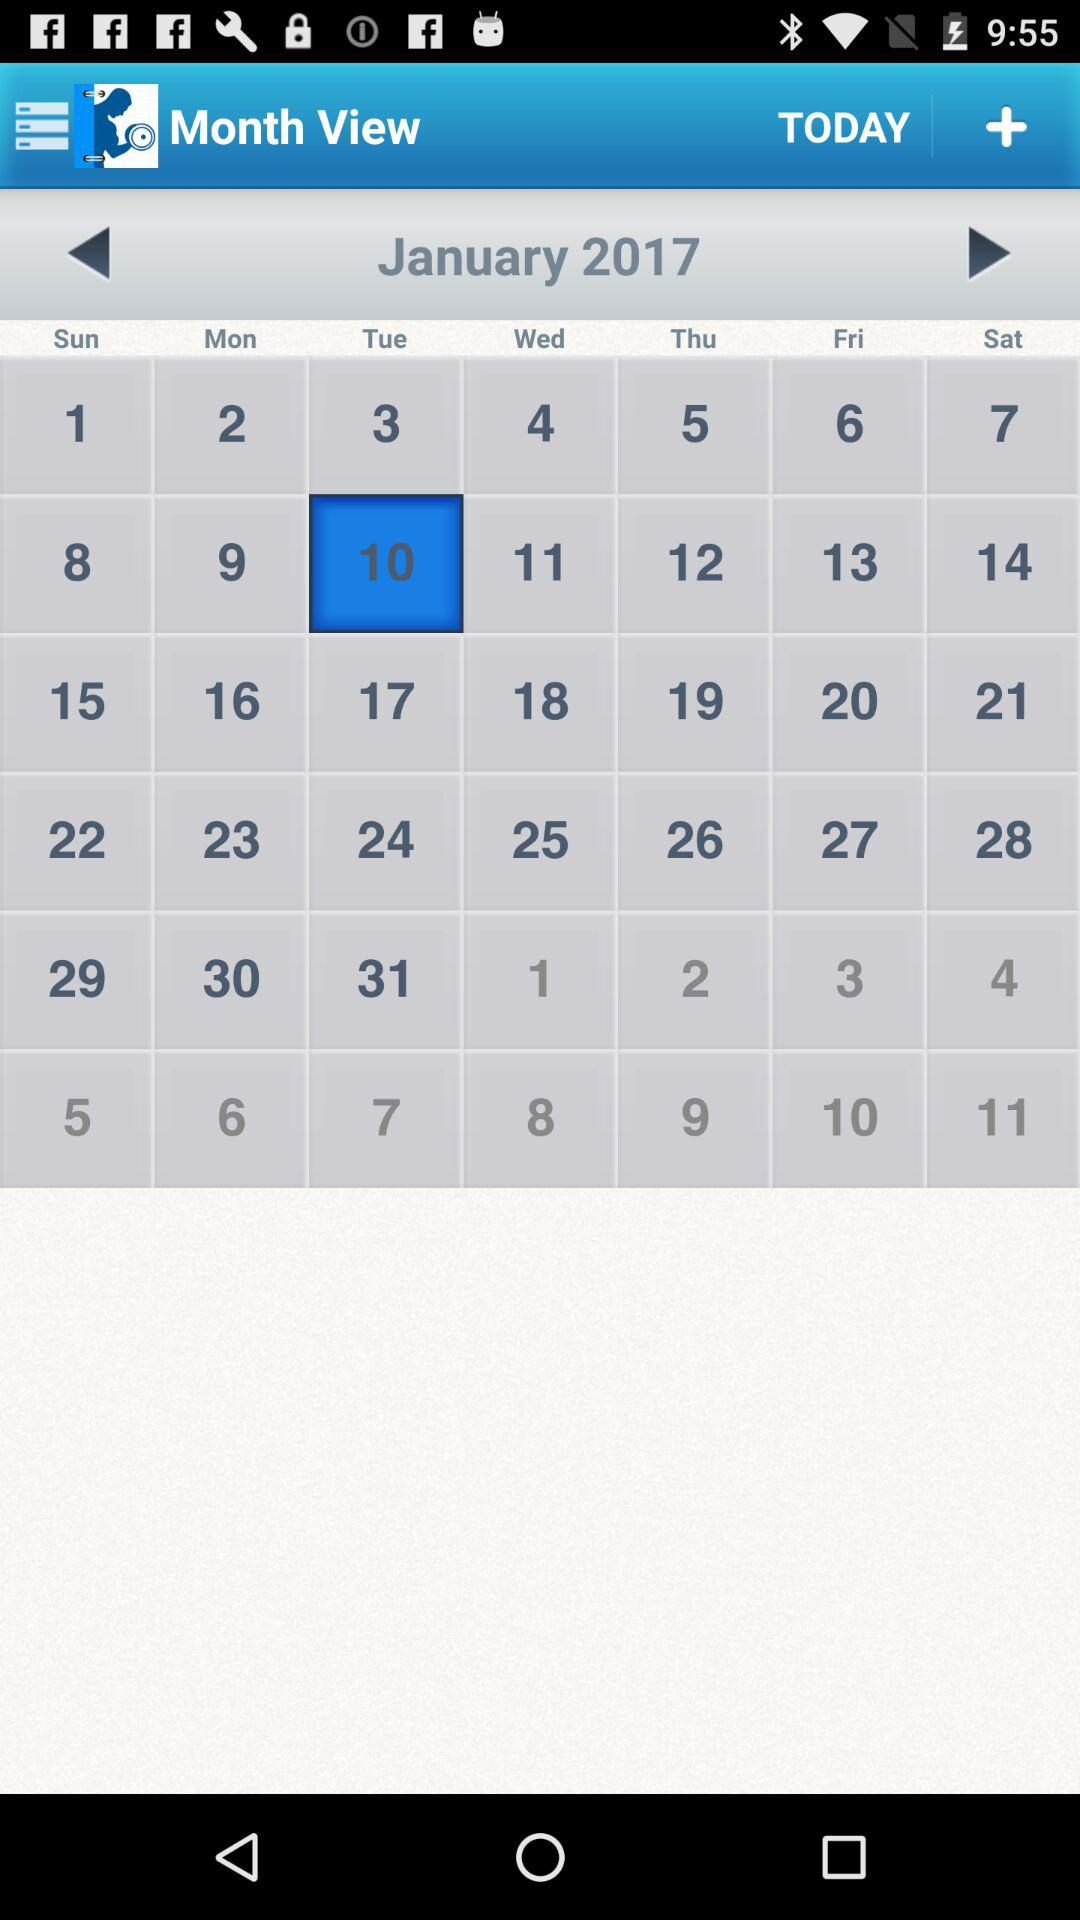Which year has been selected in the calendar? The year that has been selected is 2017. 